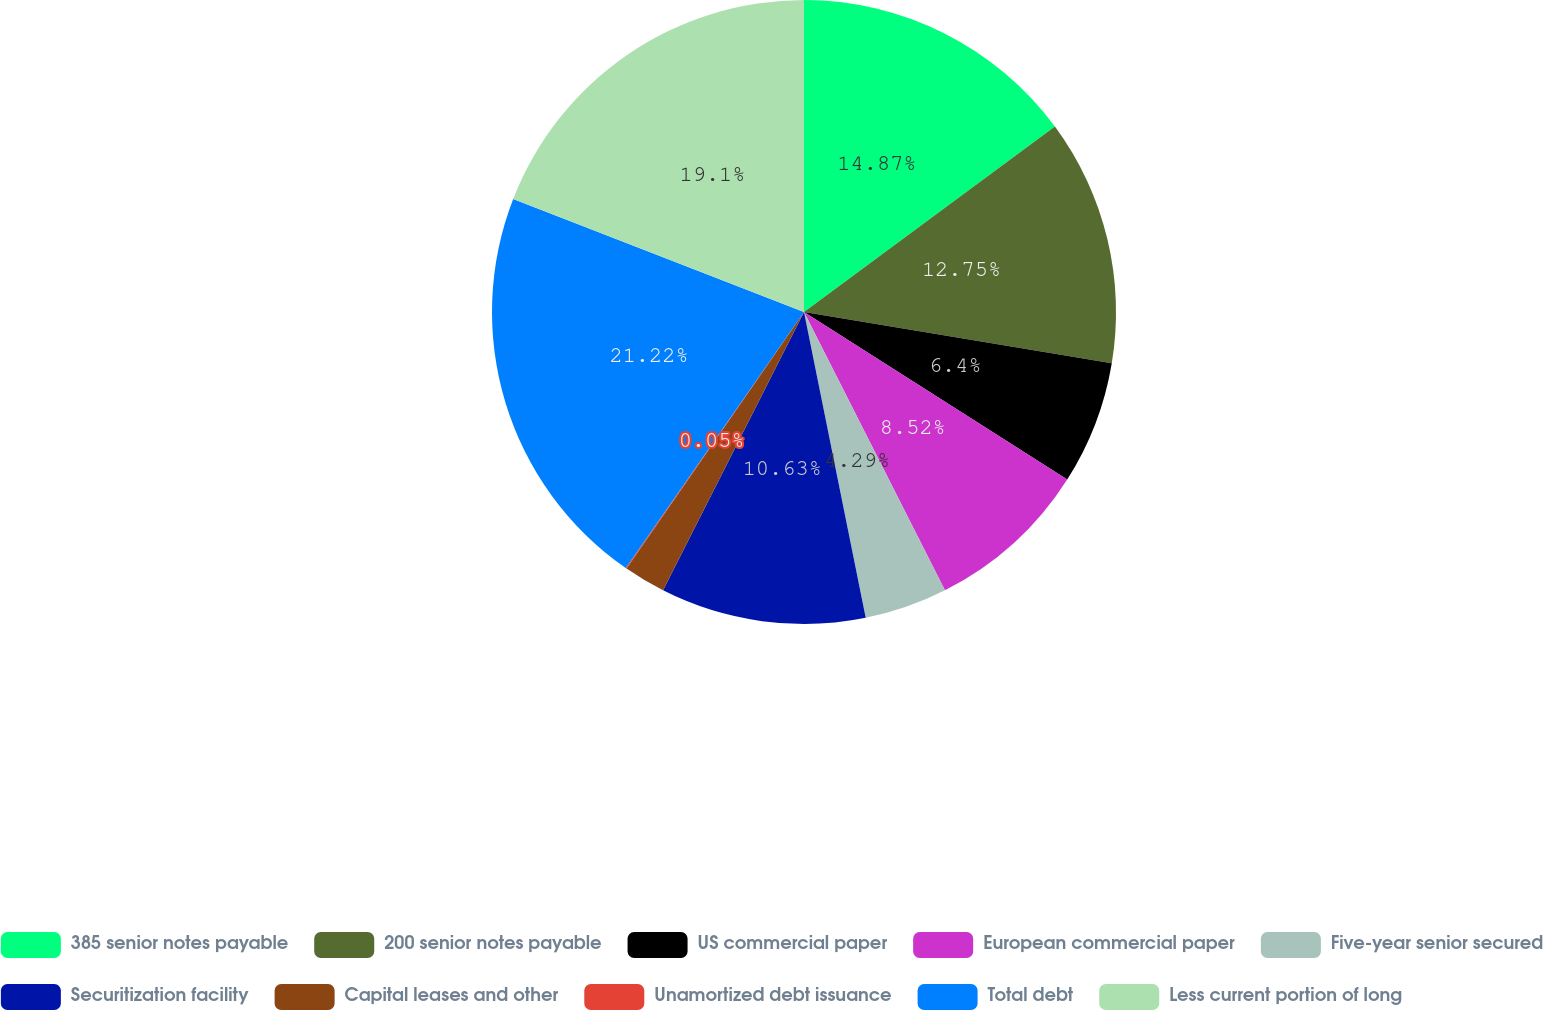Convert chart to OTSL. <chart><loc_0><loc_0><loc_500><loc_500><pie_chart><fcel>385 senior notes payable<fcel>200 senior notes payable<fcel>US commercial paper<fcel>European commercial paper<fcel>Five-year senior secured<fcel>Securitization facility<fcel>Capital leases and other<fcel>Unamortized debt issuance<fcel>Total debt<fcel>Less current portion of long<nl><fcel>14.87%<fcel>12.75%<fcel>6.4%<fcel>8.52%<fcel>4.29%<fcel>10.63%<fcel>2.17%<fcel>0.05%<fcel>21.22%<fcel>19.1%<nl></chart> 